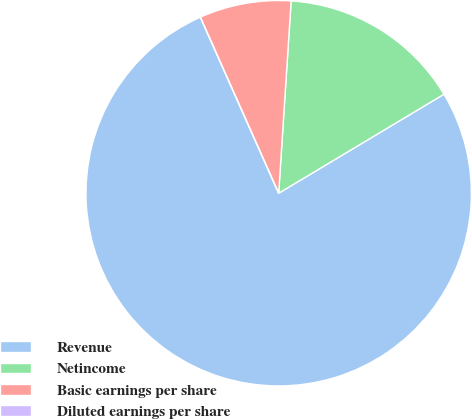<chart> <loc_0><loc_0><loc_500><loc_500><pie_chart><fcel>Revenue<fcel>Netincome<fcel>Basic earnings per share<fcel>Diluted earnings per share<nl><fcel>76.92%<fcel>15.38%<fcel>7.69%<fcel>0.0%<nl></chart> 